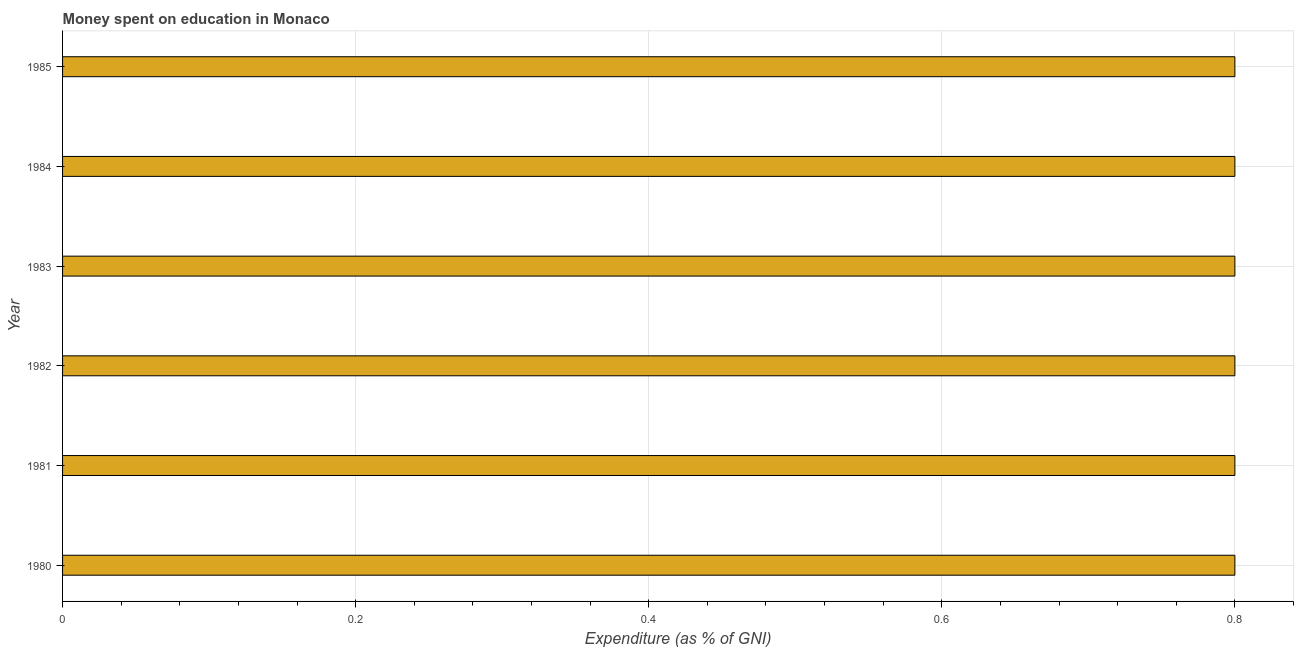Does the graph contain any zero values?
Offer a terse response. No. What is the title of the graph?
Keep it short and to the point. Money spent on education in Monaco. What is the label or title of the X-axis?
Your answer should be very brief. Expenditure (as % of GNI). What is the label or title of the Y-axis?
Your response must be concise. Year. What is the expenditure on education in 1980?
Provide a succinct answer. 0.8. Across all years, what is the minimum expenditure on education?
Make the answer very short. 0.8. In which year was the expenditure on education minimum?
Keep it short and to the point. 1980. What is the difference between the expenditure on education in 1983 and 1985?
Your answer should be very brief. 0. What is the average expenditure on education per year?
Your answer should be very brief. 0.8. In how many years, is the expenditure on education greater than 0.52 %?
Give a very brief answer. 6. Do a majority of the years between 1985 and 1983 (inclusive) have expenditure on education greater than 0.48 %?
Offer a very short reply. Yes. What is the ratio of the expenditure on education in 1980 to that in 1983?
Provide a short and direct response. 1. What is the difference between the highest and the second highest expenditure on education?
Your answer should be compact. 0. What is the difference between the highest and the lowest expenditure on education?
Ensure brevity in your answer.  0. In how many years, is the expenditure on education greater than the average expenditure on education taken over all years?
Your answer should be compact. 6. How many bars are there?
Ensure brevity in your answer.  6. What is the Expenditure (as % of GNI) of 1981?
Offer a very short reply. 0.8. What is the Expenditure (as % of GNI) in 1982?
Make the answer very short. 0.8. What is the Expenditure (as % of GNI) of 1984?
Keep it short and to the point. 0.8. What is the difference between the Expenditure (as % of GNI) in 1980 and 1982?
Keep it short and to the point. 0. What is the difference between the Expenditure (as % of GNI) in 1980 and 1983?
Your answer should be compact. 0. What is the difference between the Expenditure (as % of GNI) in 1980 and 1984?
Offer a terse response. 0. What is the difference between the Expenditure (as % of GNI) in 1980 and 1985?
Offer a terse response. 0. What is the difference between the Expenditure (as % of GNI) in 1981 and 1982?
Give a very brief answer. 0. What is the difference between the Expenditure (as % of GNI) in 1981 and 1984?
Your answer should be very brief. 0. What is the difference between the Expenditure (as % of GNI) in 1982 and 1983?
Give a very brief answer. 0. What is the difference between the Expenditure (as % of GNI) in 1982 and 1985?
Ensure brevity in your answer.  0. What is the ratio of the Expenditure (as % of GNI) in 1980 to that in 1981?
Your answer should be very brief. 1. What is the ratio of the Expenditure (as % of GNI) in 1980 to that in 1983?
Offer a very short reply. 1. What is the ratio of the Expenditure (as % of GNI) in 1980 to that in 1985?
Make the answer very short. 1. What is the ratio of the Expenditure (as % of GNI) in 1981 to that in 1982?
Your answer should be very brief. 1. What is the ratio of the Expenditure (as % of GNI) in 1981 to that in 1984?
Offer a terse response. 1. What is the ratio of the Expenditure (as % of GNI) in 1981 to that in 1985?
Your answer should be compact. 1. What is the ratio of the Expenditure (as % of GNI) in 1982 to that in 1983?
Provide a succinct answer. 1. What is the ratio of the Expenditure (as % of GNI) in 1982 to that in 1985?
Your response must be concise. 1. What is the ratio of the Expenditure (as % of GNI) in 1983 to that in 1985?
Keep it short and to the point. 1. What is the ratio of the Expenditure (as % of GNI) in 1984 to that in 1985?
Your answer should be compact. 1. 